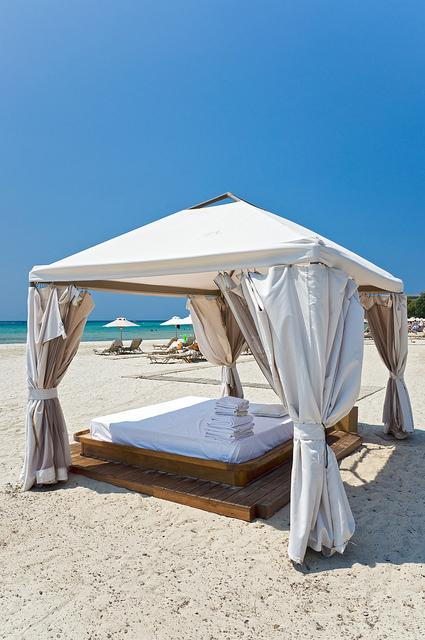What will this tent offer protection from? sun 